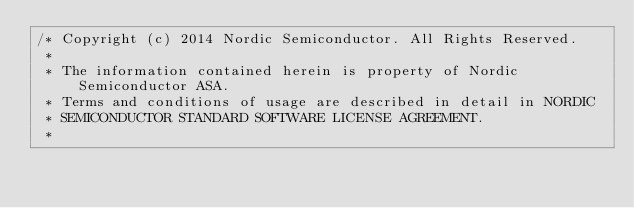<code> <loc_0><loc_0><loc_500><loc_500><_C_>/* Copyright (c) 2014 Nordic Semiconductor. All Rights Reserved.
 *
 * The information contained herein is property of Nordic Semiconductor ASA.
 * Terms and conditions of usage are described in detail in NORDIC
 * SEMICONDUCTOR STANDARD SOFTWARE LICENSE AGREEMENT.
 *</code> 